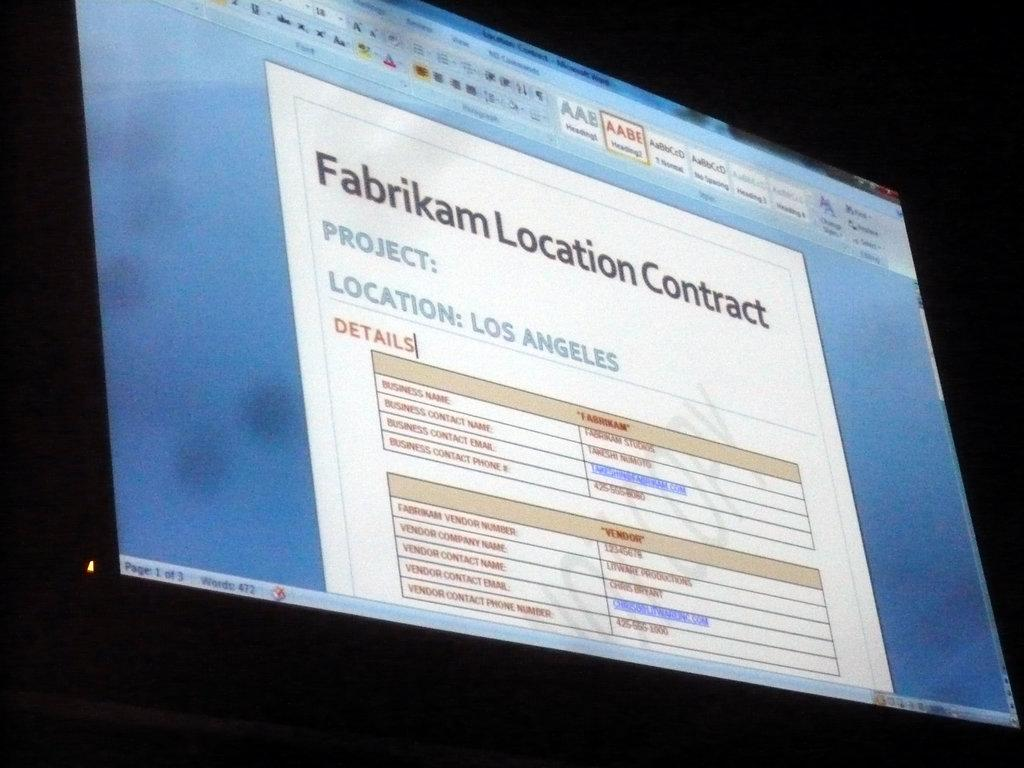Provide a one-sentence caption for the provided image. A computer screen shows a document titled "Fabrikam Location Contract.". 